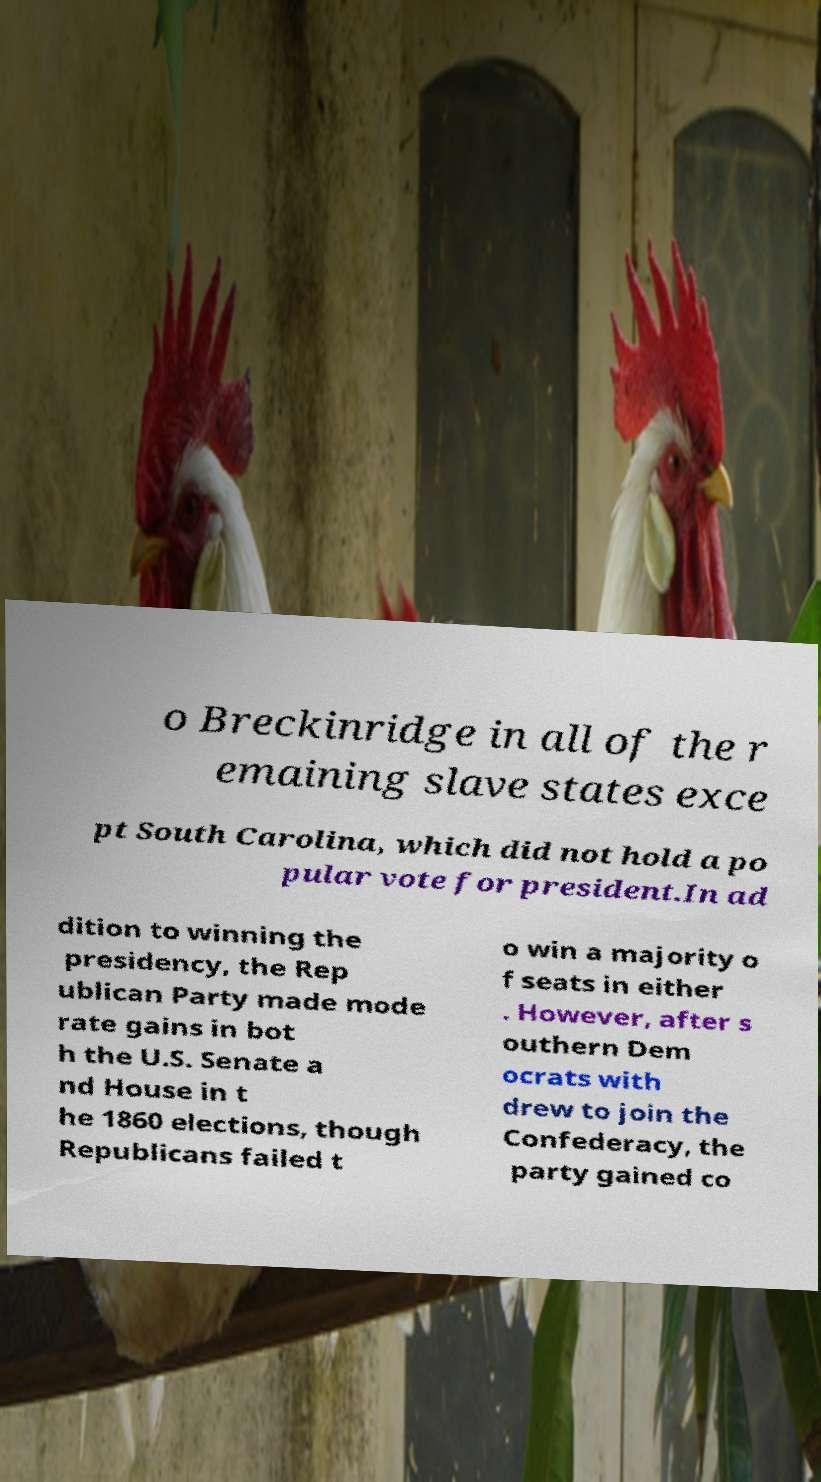Could you extract and type out the text from this image? o Breckinridge in all of the r emaining slave states exce pt South Carolina, which did not hold a po pular vote for president.In ad dition to winning the presidency, the Rep ublican Party made mode rate gains in bot h the U.S. Senate a nd House in t he 1860 elections, though Republicans failed t o win a majority o f seats in either . However, after s outhern Dem ocrats with drew to join the Confederacy, the party gained co 